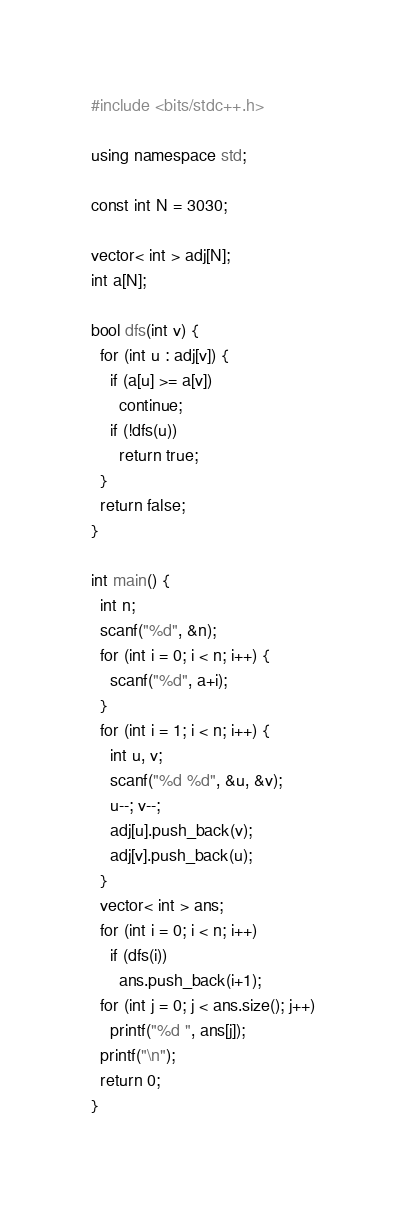Convert code to text. <code><loc_0><loc_0><loc_500><loc_500><_C++_>#include <bits/stdc++.h>

using namespace std;

const int N = 3030;

vector< int > adj[N];
int a[N];

bool dfs(int v) {
  for (int u : adj[v]) {
    if (a[u] >= a[v])
      continue;
    if (!dfs(u))
      return true;
  }
  return false;
}

int main() {
  int n;
  scanf("%d", &n);
  for (int i = 0; i < n; i++) {
    scanf("%d", a+i); 
  }
  for (int i = 1; i < n; i++) {
    int u, v;
    scanf("%d %d", &u, &v);
    u--; v--;
    adj[u].push_back(v);
    adj[v].push_back(u);
  }
  vector< int > ans;
  for (int i = 0; i < n; i++)
    if (dfs(i))
      ans.push_back(i+1);
  for (int j = 0; j < ans.size(); j++)
    printf("%d ", ans[j]);
  printf("\n");
  return 0;
}</code> 